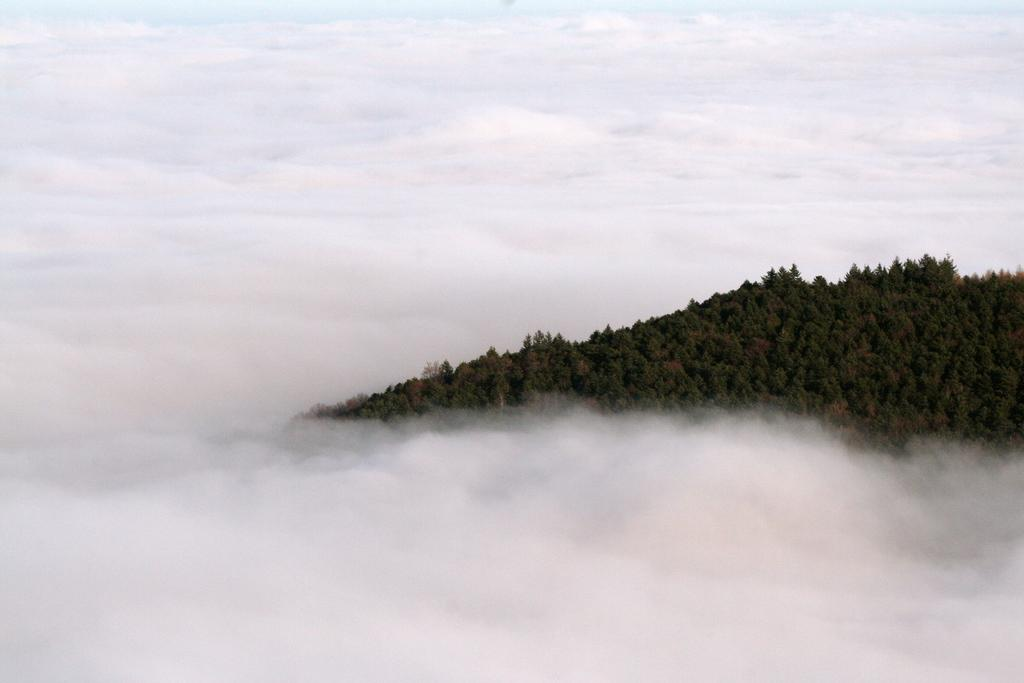What is the main feature in the image? There is a mountain in the image. What can be seen on the mountain? There are trees on the mountain. What is visible in the background of the image? The sky is visible in the background of the image. What type of lock can be seen on the mountain in the image? There is no lock present on the mountain in the image. What is the topic of the discussion taking place on the mountain in the image? There is no discussion taking place on the mountain in the image. 